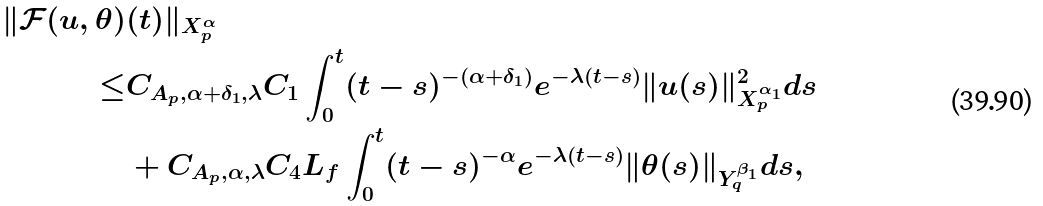<formula> <loc_0><loc_0><loc_500><loc_500>\| \mathcal { F } ( u , \theta ) & ( t ) \| _ { X ^ { \alpha } _ { p } } \\ \leq & C _ { A _ { p } , \alpha + \delta _ { 1 } , \lambda } C _ { 1 } \int ^ { t } _ { 0 } ( t - s ) ^ { - ( \alpha + \delta _ { 1 } ) } e ^ { - \lambda ( t - s ) } \| u ( s ) \| ^ { 2 } _ { X ^ { \alpha _ { 1 } } _ { p } } d s \\ & + C _ { A _ { p } , \alpha , \lambda } C _ { 4 } L _ { f } \int ^ { t } _ { 0 } ( t - s ) ^ { - \alpha } e ^ { - \lambda ( t - s ) } \| \theta ( s ) \| _ { Y ^ { \beta _ { 1 } } _ { q } } d s ,</formula> 